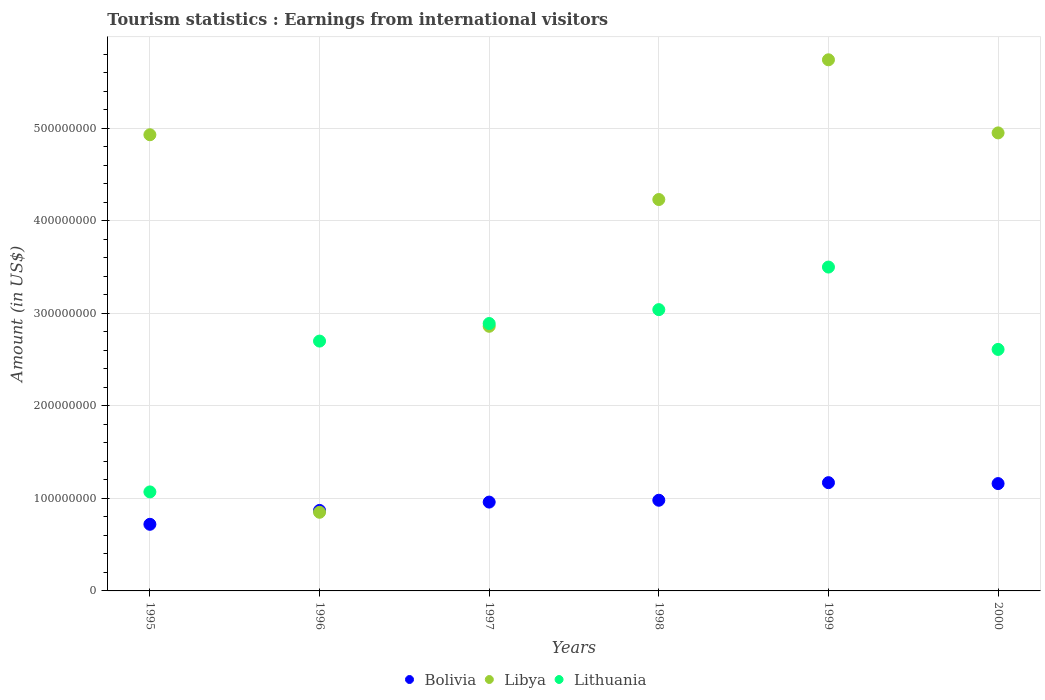How many different coloured dotlines are there?
Offer a very short reply. 3. What is the earnings from international visitors in Lithuania in 1999?
Offer a terse response. 3.50e+08. Across all years, what is the maximum earnings from international visitors in Bolivia?
Give a very brief answer. 1.17e+08. Across all years, what is the minimum earnings from international visitors in Lithuania?
Your answer should be compact. 1.07e+08. In which year was the earnings from international visitors in Libya maximum?
Keep it short and to the point. 1999. In which year was the earnings from international visitors in Libya minimum?
Your response must be concise. 1996. What is the total earnings from international visitors in Bolivia in the graph?
Provide a succinct answer. 5.86e+08. What is the difference between the earnings from international visitors in Libya in 1996 and that in 1997?
Your answer should be very brief. -2.01e+08. What is the difference between the earnings from international visitors in Lithuania in 1995 and the earnings from international visitors in Libya in 1996?
Provide a short and direct response. 2.20e+07. What is the average earnings from international visitors in Bolivia per year?
Make the answer very short. 9.77e+07. In the year 1999, what is the difference between the earnings from international visitors in Lithuania and earnings from international visitors in Libya?
Provide a short and direct response. -2.24e+08. What is the ratio of the earnings from international visitors in Bolivia in 1997 to that in 2000?
Ensure brevity in your answer.  0.83. Is the earnings from international visitors in Libya in 1995 less than that in 2000?
Offer a very short reply. Yes. Is the difference between the earnings from international visitors in Lithuania in 1996 and 2000 greater than the difference between the earnings from international visitors in Libya in 1996 and 2000?
Provide a short and direct response. Yes. What is the difference between the highest and the lowest earnings from international visitors in Bolivia?
Your answer should be very brief. 4.50e+07. Is it the case that in every year, the sum of the earnings from international visitors in Bolivia and earnings from international visitors in Lithuania  is greater than the earnings from international visitors in Libya?
Provide a short and direct response. No. Is the earnings from international visitors in Lithuania strictly less than the earnings from international visitors in Libya over the years?
Your response must be concise. No. How many dotlines are there?
Give a very brief answer. 3. Does the graph contain any zero values?
Your answer should be very brief. No. What is the title of the graph?
Give a very brief answer. Tourism statistics : Earnings from international visitors. What is the label or title of the X-axis?
Ensure brevity in your answer.  Years. What is the Amount (in US$) in Bolivia in 1995?
Make the answer very short. 7.20e+07. What is the Amount (in US$) in Libya in 1995?
Your answer should be very brief. 4.93e+08. What is the Amount (in US$) of Lithuania in 1995?
Offer a very short reply. 1.07e+08. What is the Amount (in US$) in Bolivia in 1996?
Give a very brief answer. 8.70e+07. What is the Amount (in US$) in Libya in 1996?
Your response must be concise. 8.50e+07. What is the Amount (in US$) in Lithuania in 1996?
Provide a short and direct response. 2.70e+08. What is the Amount (in US$) in Bolivia in 1997?
Offer a very short reply. 9.60e+07. What is the Amount (in US$) in Libya in 1997?
Your response must be concise. 2.86e+08. What is the Amount (in US$) in Lithuania in 1997?
Provide a succinct answer. 2.89e+08. What is the Amount (in US$) in Bolivia in 1998?
Keep it short and to the point. 9.80e+07. What is the Amount (in US$) of Libya in 1998?
Offer a very short reply. 4.23e+08. What is the Amount (in US$) of Lithuania in 1998?
Your answer should be compact. 3.04e+08. What is the Amount (in US$) of Bolivia in 1999?
Your answer should be very brief. 1.17e+08. What is the Amount (in US$) of Libya in 1999?
Ensure brevity in your answer.  5.74e+08. What is the Amount (in US$) in Lithuania in 1999?
Your response must be concise. 3.50e+08. What is the Amount (in US$) of Bolivia in 2000?
Offer a terse response. 1.16e+08. What is the Amount (in US$) of Libya in 2000?
Your answer should be very brief. 4.95e+08. What is the Amount (in US$) of Lithuania in 2000?
Ensure brevity in your answer.  2.61e+08. Across all years, what is the maximum Amount (in US$) of Bolivia?
Offer a very short reply. 1.17e+08. Across all years, what is the maximum Amount (in US$) in Libya?
Keep it short and to the point. 5.74e+08. Across all years, what is the maximum Amount (in US$) of Lithuania?
Your response must be concise. 3.50e+08. Across all years, what is the minimum Amount (in US$) in Bolivia?
Provide a short and direct response. 7.20e+07. Across all years, what is the minimum Amount (in US$) in Libya?
Give a very brief answer. 8.50e+07. Across all years, what is the minimum Amount (in US$) in Lithuania?
Keep it short and to the point. 1.07e+08. What is the total Amount (in US$) in Bolivia in the graph?
Ensure brevity in your answer.  5.86e+08. What is the total Amount (in US$) in Libya in the graph?
Provide a succinct answer. 2.36e+09. What is the total Amount (in US$) of Lithuania in the graph?
Provide a short and direct response. 1.58e+09. What is the difference between the Amount (in US$) of Bolivia in 1995 and that in 1996?
Ensure brevity in your answer.  -1.50e+07. What is the difference between the Amount (in US$) in Libya in 1995 and that in 1996?
Offer a very short reply. 4.08e+08. What is the difference between the Amount (in US$) in Lithuania in 1995 and that in 1996?
Ensure brevity in your answer.  -1.63e+08. What is the difference between the Amount (in US$) in Bolivia in 1995 and that in 1997?
Your answer should be very brief. -2.40e+07. What is the difference between the Amount (in US$) of Libya in 1995 and that in 1997?
Your answer should be compact. 2.07e+08. What is the difference between the Amount (in US$) of Lithuania in 1995 and that in 1997?
Provide a succinct answer. -1.82e+08. What is the difference between the Amount (in US$) of Bolivia in 1995 and that in 1998?
Your answer should be very brief. -2.60e+07. What is the difference between the Amount (in US$) of Libya in 1995 and that in 1998?
Your answer should be compact. 7.00e+07. What is the difference between the Amount (in US$) in Lithuania in 1995 and that in 1998?
Make the answer very short. -1.97e+08. What is the difference between the Amount (in US$) of Bolivia in 1995 and that in 1999?
Make the answer very short. -4.50e+07. What is the difference between the Amount (in US$) of Libya in 1995 and that in 1999?
Your response must be concise. -8.10e+07. What is the difference between the Amount (in US$) in Lithuania in 1995 and that in 1999?
Your answer should be compact. -2.43e+08. What is the difference between the Amount (in US$) of Bolivia in 1995 and that in 2000?
Offer a terse response. -4.40e+07. What is the difference between the Amount (in US$) in Lithuania in 1995 and that in 2000?
Your response must be concise. -1.54e+08. What is the difference between the Amount (in US$) of Bolivia in 1996 and that in 1997?
Offer a very short reply. -9.00e+06. What is the difference between the Amount (in US$) of Libya in 1996 and that in 1997?
Ensure brevity in your answer.  -2.01e+08. What is the difference between the Amount (in US$) of Lithuania in 1996 and that in 1997?
Ensure brevity in your answer.  -1.90e+07. What is the difference between the Amount (in US$) of Bolivia in 1996 and that in 1998?
Keep it short and to the point. -1.10e+07. What is the difference between the Amount (in US$) of Libya in 1996 and that in 1998?
Offer a terse response. -3.38e+08. What is the difference between the Amount (in US$) of Lithuania in 1996 and that in 1998?
Provide a short and direct response. -3.40e+07. What is the difference between the Amount (in US$) of Bolivia in 1996 and that in 1999?
Give a very brief answer. -3.00e+07. What is the difference between the Amount (in US$) of Libya in 1996 and that in 1999?
Ensure brevity in your answer.  -4.89e+08. What is the difference between the Amount (in US$) in Lithuania in 1996 and that in 1999?
Keep it short and to the point. -8.00e+07. What is the difference between the Amount (in US$) of Bolivia in 1996 and that in 2000?
Your answer should be very brief. -2.90e+07. What is the difference between the Amount (in US$) of Libya in 1996 and that in 2000?
Make the answer very short. -4.10e+08. What is the difference between the Amount (in US$) of Lithuania in 1996 and that in 2000?
Ensure brevity in your answer.  9.00e+06. What is the difference between the Amount (in US$) in Bolivia in 1997 and that in 1998?
Ensure brevity in your answer.  -2.00e+06. What is the difference between the Amount (in US$) in Libya in 1997 and that in 1998?
Your response must be concise. -1.37e+08. What is the difference between the Amount (in US$) in Lithuania in 1997 and that in 1998?
Keep it short and to the point. -1.50e+07. What is the difference between the Amount (in US$) of Bolivia in 1997 and that in 1999?
Give a very brief answer. -2.10e+07. What is the difference between the Amount (in US$) in Libya in 1997 and that in 1999?
Your response must be concise. -2.88e+08. What is the difference between the Amount (in US$) of Lithuania in 1997 and that in 1999?
Make the answer very short. -6.10e+07. What is the difference between the Amount (in US$) in Bolivia in 1997 and that in 2000?
Your answer should be compact. -2.00e+07. What is the difference between the Amount (in US$) of Libya in 1997 and that in 2000?
Your answer should be very brief. -2.09e+08. What is the difference between the Amount (in US$) of Lithuania in 1997 and that in 2000?
Provide a short and direct response. 2.80e+07. What is the difference between the Amount (in US$) in Bolivia in 1998 and that in 1999?
Make the answer very short. -1.90e+07. What is the difference between the Amount (in US$) of Libya in 1998 and that in 1999?
Make the answer very short. -1.51e+08. What is the difference between the Amount (in US$) in Lithuania in 1998 and that in 1999?
Make the answer very short. -4.60e+07. What is the difference between the Amount (in US$) of Bolivia in 1998 and that in 2000?
Ensure brevity in your answer.  -1.80e+07. What is the difference between the Amount (in US$) in Libya in 1998 and that in 2000?
Your answer should be very brief. -7.20e+07. What is the difference between the Amount (in US$) in Lithuania in 1998 and that in 2000?
Your answer should be compact. 4.30e+07. What is the difference between the Amount (in US$) in Libya in 1999 and that in 2000?
Your response must be concise. 7.90e+07. What is the difference between the Amount (in US$) in Lithuania in 1999 and that in 2000?
Make the answer very short. 8.90e+07. What is the difference between the Amount (in US$) in Bolivia in 1995 and the Amount (in US$) in Libya in 1996?
Keep it short and to the point. -1.30e+07. What is the difference between the Amount (in US$) in Bolivia in 1995 and the Amount (in US$) in Lithuania in 1996?
Keep it short and to the point. -1.98e+08. What is the difference between the Amount (in US$) of Libya in 1995 and the Amount (in US$) of Lithuania in 1996?
Ensure brevity in your answer.  2.23e+08. What is the difference between the Amount (in US$) in Bolivia in 1995 and the Amount (in US$) in Libya in 1997?
Offer a terse response. -2.14e+08. What is the difference between the Amount (in US$) in Bolivia in 1995 and the Amount (in US$) in Lithuania in 1997?
Your answer should be compact. -2.17e+08. What is the difference between the Amount (in US$) of Libya in 1995 and the Amount (in US$) of Lithuania in 1997?
Your response must be concise. 2.04e+08. What is the difference between the Amount (in US$) in Bolivia in 1995 and the Amount (in US$) in Libya in 1998?
Offer a very short reply. -3.51e+08. What is the difference between the Amount (in US$) in Bolivia in 1995 and the Amount (in US$) in Lithuania in 1998?
Your answer should be compact. -2.32e+08. What is the difference between the Amount (in US$) in Libya in 1995 and the Amount (in US$) in Lithuania in 1998?
Provide a succinct answer. 1.89e+08. What is the difference between the Amount (in US$) of Bolivia in 1995 and the Amount (in US$) of Libya in 1999?
Your answer should be compact. -5.02e+08. What is the difference between the Amount (in US$) in Bolivia in 1995 and the Amount (in US$) in Lithuania in 1999?
Your response must be concise. -2.78e+08. What is the difference between the Amount (in US$) in Libya in 1995 and the Amount (in US$) in Lithuania in 1999?
Your response must be concise. 1.43e+08. What is the difference between the Amount (in US$) of Bolivia in 1995 and the Amount (in US$) of Libya in 2000?
Keep it short and to the point. -4.23e+08. What is the difference between the Amount (in US$) of Bolivia in 1995 and the Amount (in US$) of Lithuania in 2000?
Keep it short and to the point. -1.89e+08. What is the difference between the Amount (in US$) of Libya in 1995 and the Amount (in US$) of Lithuania in 2000?
Provide a short and direct response. 2.32e+08. What is the difference between the Amount (in US$) of Bolivia in 1996 and the Amount (in US$) of Libya in 1997?
Your answer should be very brief. -1.99e+08. What is the difference between the Amount (in US$) of Bolivia in 1996 and the Amount (in US$) of Lithuania in 1997?
Offer a terse response. -2.02e+08. What is the difference between the Amount (in US$) of Libya in 1996 and the Amount (in US$) of Lithuania in 1997?
Ensure brevity in your answer.  -2.04e+08. What is the difference between the Amount (in US$) of Bolivia in 1996 and the Amount (in US$) of Libya in 1998?
Offer a very short reply. -3.36e+08. What is the difference between the Amount (in US$) in Bolivia in 1996 and the Amount (in US$) in Lithuania in 1998?
Make the answer very short. -2.17e+08. What is the difference between the Amount (in US$) of Libya in 1996 and the Amount (in US$) of Lithuania in 1998?
Offer a very short reply. -2.19e+08. What is the difference between the Amount (in US$) in Bolivia in 1996 and the Amount (in US$) in Libya in 1999?
Keep it short and to the point. -4.87e+08. What is the difference between the Amount (in US$) of Bolivia in 1996 and the Amount (in US$) of Lithuania in 1999?
Ensure brevity in your answer.  -2.63e+08. What is the difference between the Amount (in US$) of Libya in 1996 and the Amount (in US$) of Lithuania in 1999?
Keep it short and to the point. -2.65e+08. What is the difference between the Amount (in US$) of Bolivia in 1996 and the Amount (in US$) of Libya in 2000?
Provide a succinct answer. -4.08e+08. What is the difference between the Amount (in US$) of Bolivia in 1996 and the Amount (in US$) of Lithuania in 2000?
Provide a succinct answer. -1.74e+08. What is the difference between the Amount (in US$) in Libya in 1996 and the Amount (in US$) in Lithuania in 2000?
Offer a terse response. -1.76e+08. What is the difference between the Amount (in US$) of Bolivia in 1997 and the Amount (in US$) of Libya in 1998?
Provide a succinct answer. -3.27e+08. What is the difference between the Amount (in US$) in Bolivia in 1997 and the Amount (in US$) in Lithuania in 1998?
Ensure brevity in your answer.  -2.08e+08. What is the difference between the Amount (in US$) in Libya in 1997 and the Amount (in US$) in Lithuania in 1998?
Provide a short and direct response. -1.80e+07. What is the difference between the Amount (in US$) in Bolivia in 1997 and the Amount (in US$) in Libya in 1999?
Your answer should be very brief. -4.78e+08. What is the difference between the Amount (in US$) in Bolivia in 1997 and the Amount (in US$) in Lithuania in 1999?
Your answer should be very brief. -2.54e+08. What is the difference between the Amount (in US$) in Libya in 1997 and the Amount (in US$) in Lithuania in 1999?
Provide a short and direct response. -6.40e+07. What is the difference between the Amount (in US$) of Bolivia in 1997 and the Amount (in US$) of Libya in 2000?
Your answer should be very brief. -3.99e+08. What is the difference between the Amount (in US$) in Bolivia in 1997 and the Amount (in US$) in Lithuania in 2000?
Make the answer very short. -1.65e+08. What is the difference between the Amount (in US$) of Libya in 1997 and the Amount (in US$) of Lithuania in 2000?
Provide a succinct answer. 2.50e+07. What is the difference between the Amount (in US$) of Bolivia in 1998 and the Amount (in US$) of Libya in 1999?
Provide a short and direct response. -4.76e+08. What is the difference between the Amount (in US$) of Bolivia in 1998 and the Amount (in US$) of Lithuania in 1999?
Keep it short and to the point. -2.52e+08. What is the difference between the Amount (in US$) of Libya in 1998 and the Amount (in US$) of Lithuania in 1999?
Provide a succinct answer. 7.30e+07. What is the difference between the Amount (in US$) of Bolivia in 1998 and the Amount (in US$) of Libya in 2000?
Keep it short and to the point. -3.97e+08. What is the difference between the Amount (in US$) of Bolivia in 1998 and the Amount (in US$) of Lithuania in 2000?
Your answer should be very brief. -1.63e+08. What is the difference between the Amount (in US$) in Libya in 1998 and the Amount (in US$) in Lithuania in 2000?
Provide a short and direct response. 1.62e+08. What is the difference between the Amount (in US$) in Bolivia in 1999 and the Amount (in US$) in Libya in 2000?
Ensure brevity in your answer.  -3.78e+08. What is the difference between the Amount (in US$) in Bolivia in 1999 and the Amount (in US$) in Lithuania in 2000?
Provide a succinct answer. -1.44e+08. What is the difference between the Amount (in US$) in Libya in 1999 and the Amount (in US$) in Lithuania in 2000?
Your response must be concise. 3.13e+08. What is the average Amount (in US$) of Bolivia per year?
Offer a terse response. 9.77e+07. What is the average Amount (in US$) of Libya per year?
Make the answer very short. 3.93e+08. What is the average Amount (in US$) of Lithuania per year?
Your answer should be compact. 2.64e+08. In the year 1995, what is the difference between the Amount (in US$) of Bolivia and Amount (in US$) of Libya?
Offer a terse response. -4.21e+08. In the year 1995, what is the difference between the Amount (in US$) of Bolivia and Amount (in US$) of Lithuania?
Keep it short and to the point. -3.50e+07. In the year 1995, what is the difference between the Amount (in US$) in Libya and Amount (in US$) in Lithuania?
Provide a succinct answer. 3.86e+08. In the year 1996, what is the difference between the Amount (in US$) in Bolivia and Amount (in US$) in Libya?
Your response must be concise. 2.00e+06. In the year 1996, what is the difference between the Amount (in US$) in Bolivia and Amount (in US$) in Lithuania?
Give a very brief answer. -1.83e+08. In the year 1996, what is the difference between the Amount (in US$) in Libya and Amount (in US$) in Lithuania?
Your answer should be compact. -1.85e+08. In the year 1997, what is the difference between the Amount (in US$) of Bolivia and Amount (in US$) of Libya?
Offer a very short reply. -1.90e+08. In the year 1997, what is the difference between the Amount (in US$) of Bolivia and Amount (in US$) of Lithuania?
Provide a succinct answer. -1.93e+08. In the year 1997, what is the difference between the Amount (in US$) of Libya and Amount (in US$) of Lithuania?
Offer a very short reply. -3.00e+06. In the year 1998, what is the difference between the Amount (in US$) of Bolivia and Amount (in US$) of Libya?
Make the answer very short. -3.25e+08. In the year 1998, what is the difference between the Amount (in US$) of Bolivia and Amount (in US$) of Lithuania?
Give a very brief answer. -2.06e+08. In the year 1998, what is the difference between the Amount (in US$) in Libya and Amount (in US$) in Lithuania?
Offer a terse response. 1.19e+08. In the year 1999, what is the difference between the Amount (in US$) in Bolivia and Amount (in US$) in Libya?
Give a very brief answer. -4.57e+08. In the year 1999, what is the difference between the Amount (in US$) of Bolivia and Amount (in US$) of Lithuania?
Ensure brevity in your answer.  -2.33e+08. In the year 1999, what is the difference between the Amount (in US$) of Libya and Amount (in US$) of Lithuania?
Offer a very short reply. 2.24e+08. In the year 2000, what is the difference between the Amount (in US$) in Bolivia and Amount (in US$) in Libya?
Offer a terse response. -3.79e+08. In the year 2000, what is the difference between the Amount (in US$) of Bolivia and Amount (in US$) of Lithuania?
Provide a short and direct response. -1.45e+08. In the year 2000, what is the difference between the Amount (in US$) in Libya and Amount (in US$) in Lithuania?
Provide a short and direct response. 2.34e+08. What is the ratio of the Amount (in US$) in Bolivia in 1995 to that in 1996?
Give a very brief answer. 0.83. What is the ratio of the Amount (in US$) of Lithuania in 1995 to that in 1996?
Provide a succinct answer. 0.4. What is the ratio of the Amount (in US$) of Libya in 1995 to that in 1997?
Your response must be concise. 1.72. What is the ratio of the Amount (in US$) of Lithuania in 1995 to that in 1997?
Provide a succinct answer. 0.37. What is the ratio of the Amount (in US$) of Bolivia in 1995 to that in 1998?
Your answer should be very brief. 0.73. What is the ratio of the Amount (in US$) of Libya in 1995 to that in 1998?
Offer a terse response. 1.17. What is the ratio of the Amount (in US$) in Lithuania in 1995 to that in 1998?
Keep it short and to the point. 0.35. What is the ratio of the Amount (in US$) in Bolivia in 1995 to that in 1999?
Make the answer very short. 0.62. What is the ratio of the Amount (in US$) in Libya in 1995 to that in 1999?
Your response must be concise. 0.86. What is the ratio of the Amount (in US$) in Lithuania in 1995 to that in 1999?
Offer a terse response. 0.31. What is the ratio of the Amount (in US$) of Bolivia in 1995 to that in 2000?
Ensure brevity in your answer.  0.62. What is the ratio of the Amount (in US$) in Libya in 1995 to that in 2000?
Your answer should be compact. 1. What is the ratio of the Amount (in US$) in Lithuania in 1995 to that in 2000?
Give a very brief answer. 0.41. What is the ratio of the Amount (in US$) in Bolivia in 1996 to that in 1997?
Provide a succinct answer. 0.91. What is the ratio of the Amount (in US$) of Libya in 1996 to that in 1997?
Give a very brief answer. 0.3. What is the ratio of the Amount (in US$) of Lithuania in 1996 to that in 1997?
Your answer should be very brief. 0.93. What is the ratio of the Amount (in US$) in Bolivia in 1996 to that in 1998?
Your answer should be compact. 0.89. What is the ratio of the Amount (in US$) in Libya in 1996 to that in 1998?
Provide a succinct answer. 0.2. What is the ratio of the Amount (in US$) of Lithuania in 1996 to that in 1998?
Provide a succinct answer. 0.89. What is the ratio of the Amount (in US$) in Bolivia in 1996 to that in 1999?
Make the answer very short. 0.74. What is the ratio of the Amount (in US$) of Libya in 1996 to that in 1999?
Offer a terse response. 0.15. What is the ratio of the Amount (in US$) of Lithuania in 1996 to that in 1999?
Provide a short and direct response. 0.77. What is the ratio of the Amount (in US$) in Libya in 1996 to that in 2000?
Your answer should be compact. 0.17. What is the ratio of the Amount (in US$) of Lithuania in 1996 to that in 2000?
Provide a short and direct response. 1.03. What is the ratio of the Amount (in US$) of Bolivia in 1997 to that in 1998?
Your answer should be compact. 0.98. What is the ratio of the Amount (in US$) in Libya in 1997 to that in 1998?
Provide a succinct answer. 0.68. What is the ratio of the Amount (in US$) in Lithuania in 1997 to that in 1998?
Offer a very short reply. 0.95. What is the ratio of the Amount (in US$) in Bolivia in 1997 to that in 1999?
Keep it short and to the point. 0.82. What is the ratio of the Amount (in US$) of Libya in 1997 to that in 1999?
Make the answer very short. 0.5. What is the ratio of the Amount (in US$) in Lithuania in 1997 to that in 1999?
Make the answer very short. 0.83. What is the ratio of the Amount (in US$) in Bolivia in 1997 to that in 2000?
Provide a succinct answer. 0.83. What is the ratio of the Amount (in US$) in Libya in 1997 to that in 2000?
Make the answer very short. 0.58. What is the ratio of the Amount (in US$) in Lithuania in 1997 to that in 2000?
Offer a terse response. 1.11. What is the ratio of the Amount (in US$) of Bolivia in 1998 to that in 1999?
Your response must be concise. 0.84. What is the ratio of the Amount (in US$) of Libya in 1998 to that in 1999?
Give a very brief answer. 0.74. What is the ratio of the Amount (in US$) of Lithuania in 1998 to that in 1999?
Provide a succinct answer. 0.87. What is the ratio of the Amount (in US$) of Bolivia in 1998 to that in 2000?
Your response must be concise. 0.84. What is the ratio of the Amount (in US$) of Libya in 1998 to that in 2000?
Make the answer very short. 0.85. What is the ratio of the Amount (in US$) in Lithuania in 1998 to that in 2000?
Provide a short and direct response. 1.16. What is the ratio of the Amount (in US$) of Bolivia in 1999 to that in 2000?
Keep it short and to the point. 1.01. What is the ratio of the Amount (in US$) of Libya in 1999 to that in 2000?
Provide a succinct answer. 1.16. What is the ratio of the Amount (in US$) of Lithuania in 1999 to that in 2000?
Your answer should be very brief. 1.34. What is the difference between the highest and the second highest Amount (in US$) of Libya?
Your answer should be compact. 7.90e+07. What is the difference between the highest and the second highest Amount (in US$) in Lithuania?
Your answer should be compact. 4.60e+07. What is the difference between the highest and the lowest Amount (in US$) of Bolivia?
Offer a very short reply. 4.50e+07. What is the difference between the highest and the lowest Amount (in US$) of Libya?
Your answer should be very brief. 4.89e+08. What is the difference between the highest and the lowest Amount (in US$) in Lithuania?
Provide a short and direct response. 2.43e+08. 